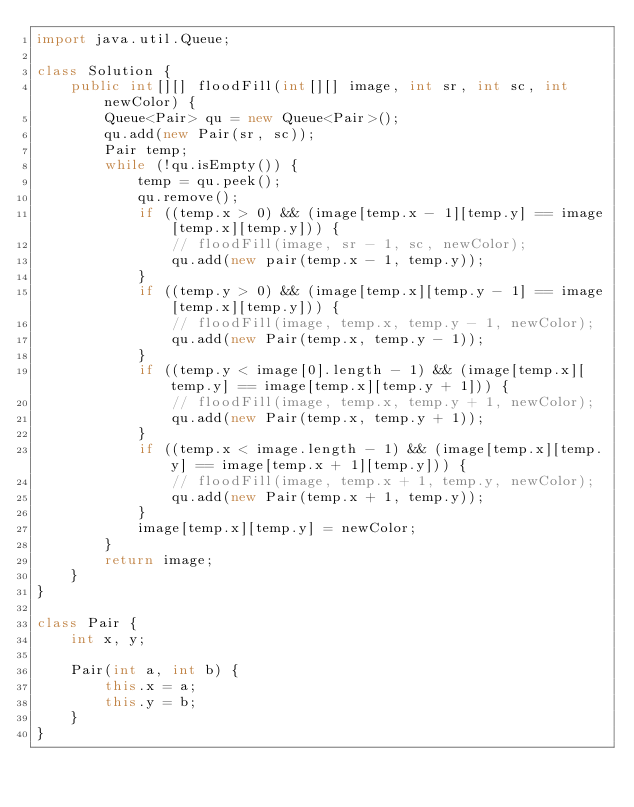<code> <loc_0><loc_0><loc_500><loc_500><_Java_>import java.util.Queue;

class Solution {
    public int[][] floodFill(int[][] image, int sr, int sc, int newColor) {
        Queue<Pair> qu = new Queue<Pair>();
        qu.add(new Pair(sr, sc));
        Pair temp;
        while (!qu.isEmpty()) {
            temp = qu.peek();
            qu.remove();
            if ((temp.x > 0) && (image[temp.x - 1][temp.y] == image[temp.x][temp.y])) {
                // floodFill(image, sr - 1, sc, newColor);
                qu.add(new pair(temp.x - 1, temp.y));
            }
            if ((temp.y > 0) && (image[temp.x][temp.y - 1] == image[temp.x][temp.y])) {
                // floodFill(image, temp.x, temp.y - 1, newColor);
                qu.add(new Pair(temp.x, temp.y - 1));
            }
            if ((temp.y < image[0].length - 1) && (image[temp.x][temp.y] == image[temp.x][temp.y + 1])) {
                // floodFill(image, temp.x, temp.y + 1, newColor);
                qu.add(new Pair(temp.x, temp.y + 1));
            }
            if ((temp.x < image.length - 1) && (image[temp.x][temp.y] == image[temp.x + 1][temp.y])) {
                // floodFill(image, temp.x + 1, temp.y, newColor);
                qu.add(new Pair(temp.x + 1, temp.y));
            }
            image[temp.x][temp.y] = newColor;
        }
        return image;
    }
}

class Pair {
    int x, y;

    Pair(int a, int b) {
        this.x = a;
        this.y = b;
    }
}</code> 